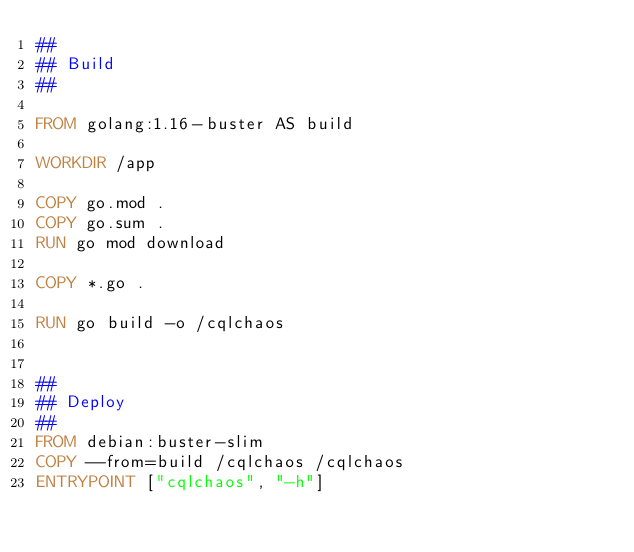Convert code to text. <code><loc_0><loc_0><loc_500><loc_500><_Dockerfile_>##
## Build
##

FROM golang:1.16-buster AS build

WORKDIR /app

COPY go.mod .
COPY go.sum .
RUN go mod download

COPY *.go .

RUN go build -o /cqlchaos


##
## Deploy
##
FROM debian:buster-slim
COPY --from=build /cqlchaos /cqlchaos
ENTRYPOINT ["cqlchaos", "-h"]
</code> 